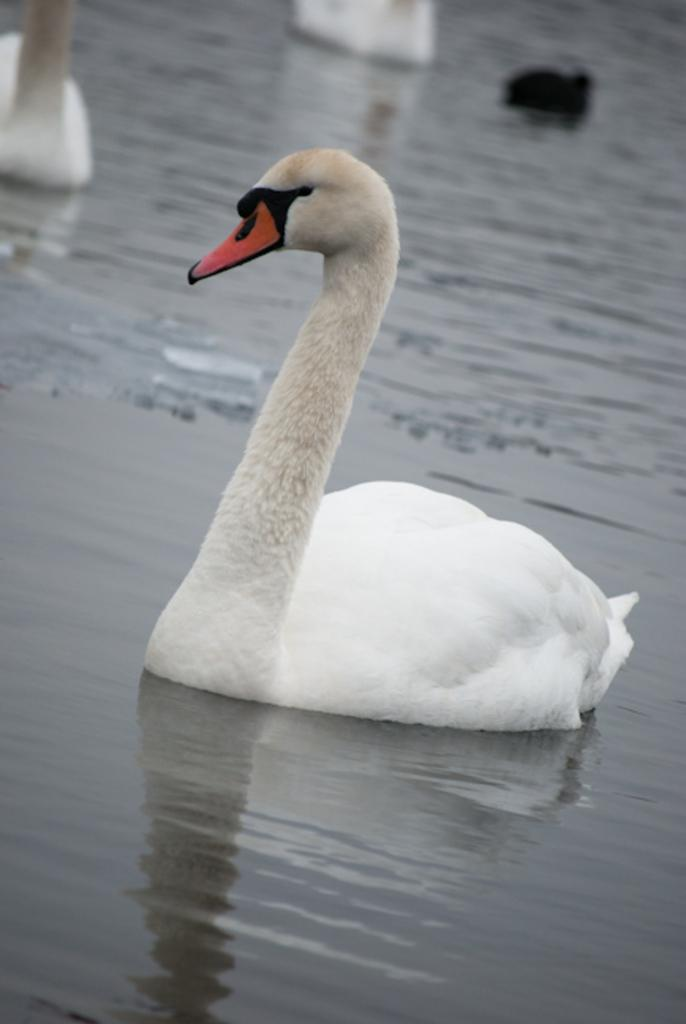What animals are present in the image? There are swans in the image. Where are the swans located? The swans are in the water. What type of mailbox can be seen near the swans in the image? There is no mailbox present in the image; it features swans in the water. How comfortable are the swans in the image? The comfort level of the swans cannot be determined from the image, as it only shows them in the water. 